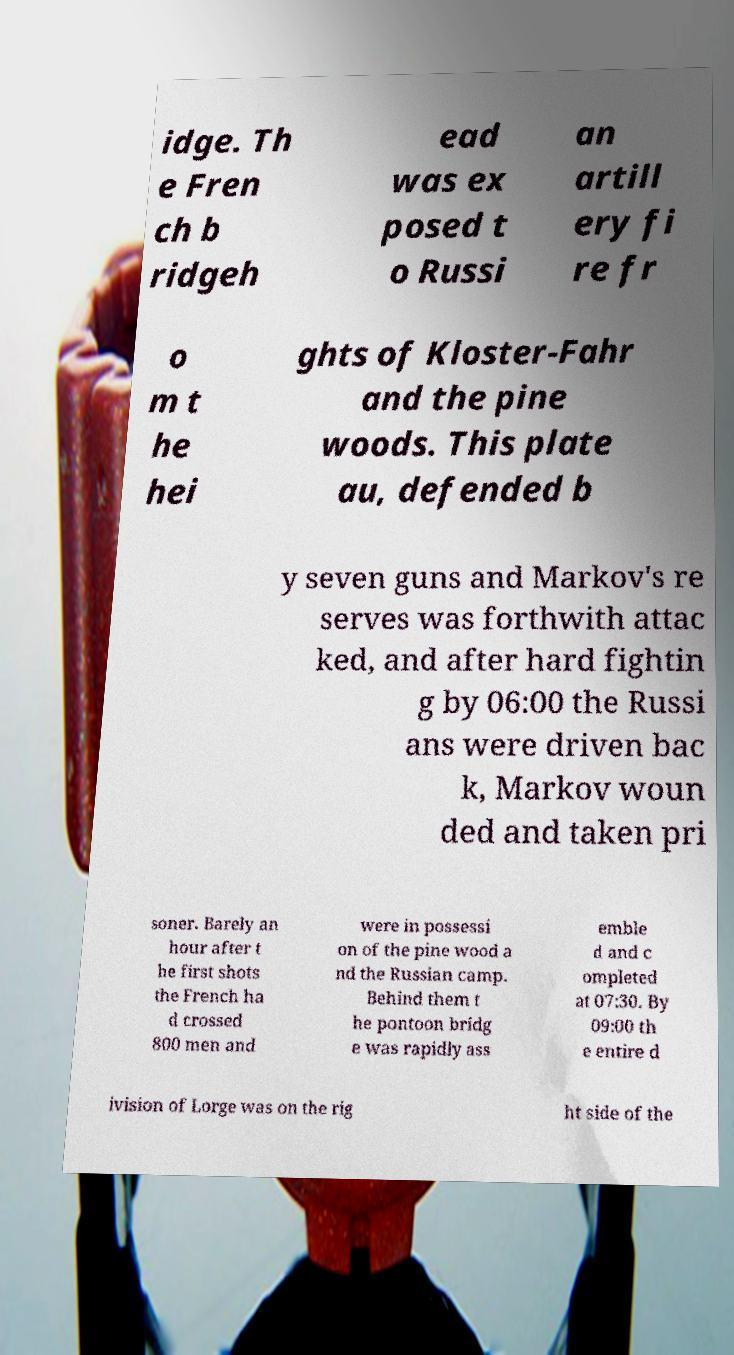Please read and relay the text visible in this image. What does it say? idge. Th e Fren ch b ridgeh ead was ex posed t o Russi an artill ery fi re fr o m t he hei ghts of Kloster-Fahr and the pine woods. This plate au, defended b y seven guns and Markov's re serves was forthwith attac ked, and after hard fightin g by 06:00 the Russi ans were driven bac k, Markov woun ded and taken pri soner. Barely an hour after t he first shots the French ha d crossed 800 men and were in possessi on of the pine wood a nd the Russian camp. Behind them t he pontoon bridg e was rapidly ass emble d and c ompleted at 07:30. By 09:00 th e entire d ivision of Lorge was on the rig ht side of the 